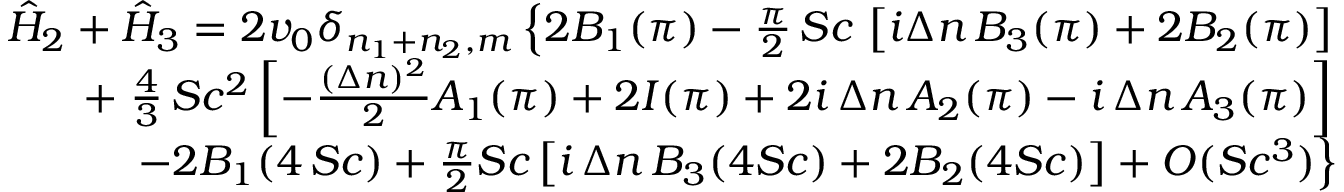Convert formula to latex. <formula><loc_0><loc_0><loc_500><loc_500>\begin{array} { r l r } & { \hat { H } _ { 2 } + \hat { H } _ { 3 } = 2 v _ { 0 } \delta _ { n _ { 1 } + n _ { 2 } , m } \left \{ 2 B _ { 1 } ( \pi ) - { \frac { \pi } { 2 } } \, S c \, \left [ i \Delta n \, B _ { 3 } ( \pi ) + 2 B _ { 2 } ( \pi ) \right ] } \\ & { + { \frac { 4 } { 3 } } \, S c ^ { 2 } \left [ - { \frac { ( \Delta n ) ^ { 2 } } { 2 } } A _ { 1 } ( \pi ) + 2 I ( \pi ) + 2 i \, \Delta n \, A _ { 2 } ( \pi ) - i \, \Delta n \, A _ { 3 } ( \pi ) \right ] } \\ & { - 2 B _ { 1 } ( 4 \, S c ) + { \frac { \pi } { 2 } } S c \left [ i \, \Delta n \, B _ { 3 } ( 4 S c ) + 2 B _ { 2 } ( 4 S c ) \right ] + O ( S c ^ { 3 } ) \right \} } \end{array}</formula> 